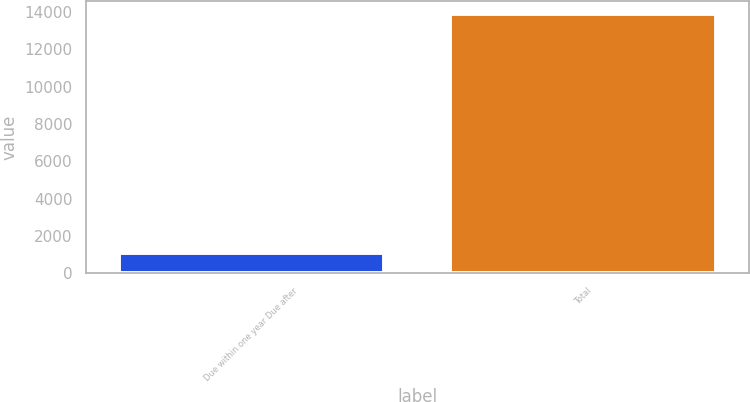Convert chart. <chart><loc_0><loc_0><loc_500><loc_500><bar_chart><fcel>Due within one year Due after<fcel>Total<nl><fcel>1086<fcel>13884<nl></chart> 